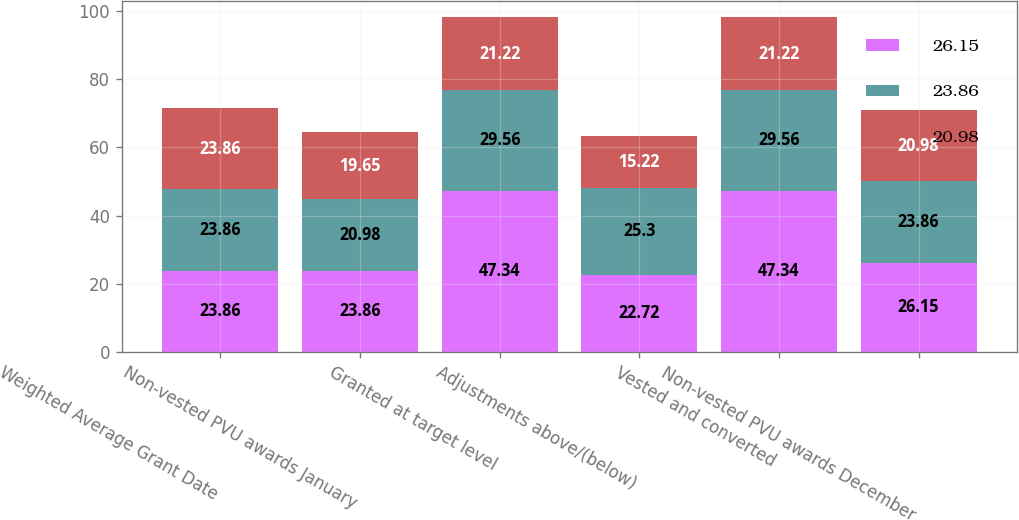Convert chart to OTSL. <chart><loc_0><loc_0><loc_500><loc_500><stacked_bar_chart><ecel><fcel>Weighted Average Grant Date<fcel>Non-vested PVU awards January<fcel>Granted at target level<fcel>Adjustments above/(below)<fcel>Vested and converted<fcel>Non-vested PVU awards December<nl><fcel>26.15<fcel>23.86<fcel>23.86<fcel>47.34<fcel>22.72<fcel>47.34<fcel>26.15<nl><fcel>23.86<fcel>23.86<fcel>20.98<fcel>29.56<fcel>25.3<fcel>29.56<fcel>23.86<nl><fcel>20.98<fcel>23.86<fcel>19.65<fcel>21.22<fcel>15.22<fcel>21.22<fcel>20.98<nl></chart> 